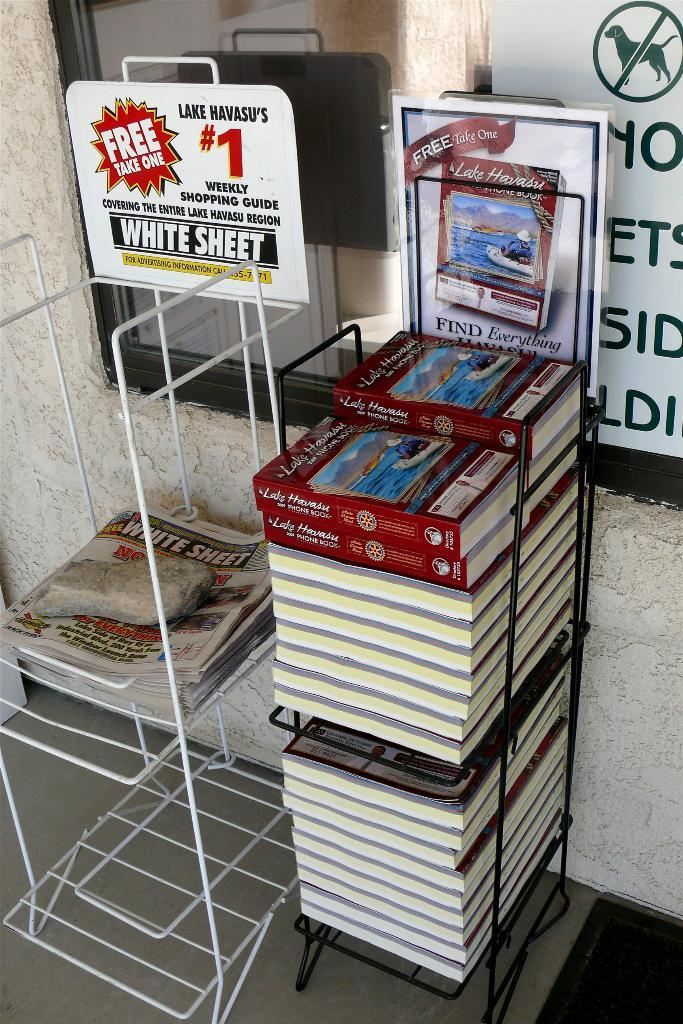<image>
Summarize the visual content of the image. The White Sheet claims to be Lake Havasu's number one weekly shopping guide. 